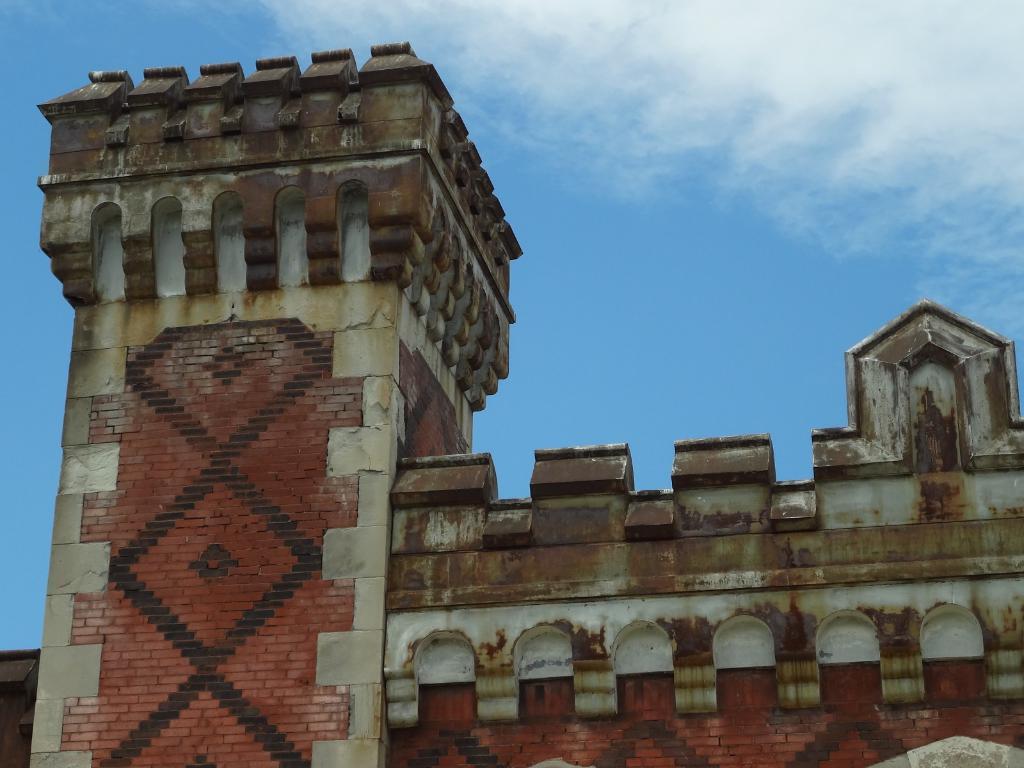How would you summarize this image in a sentence or two? Here there is a building, this is sky. 